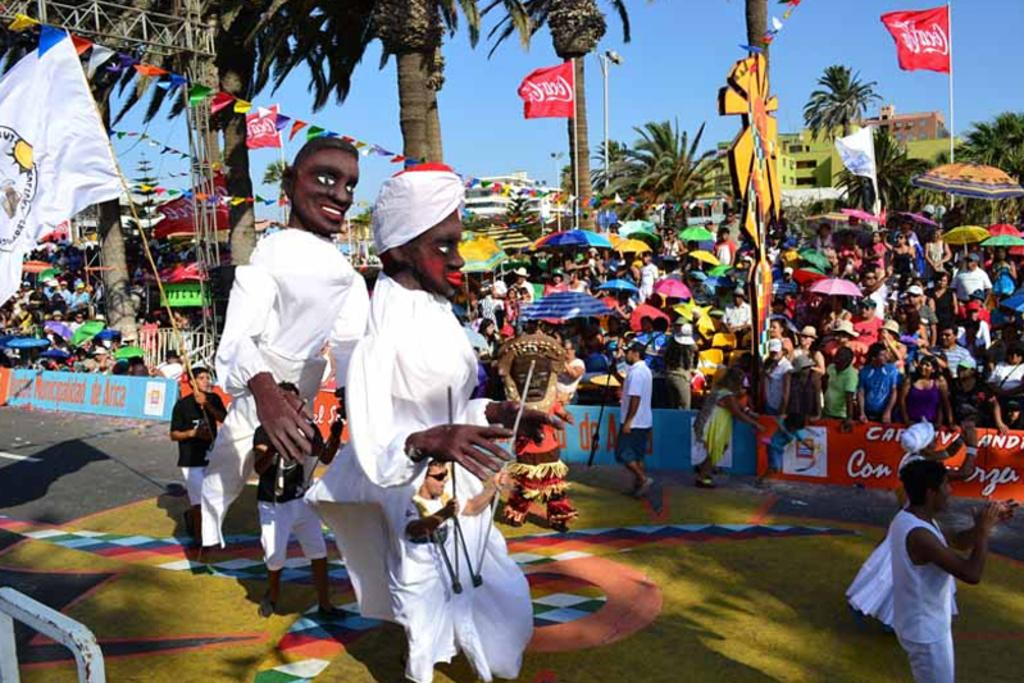<image>
Provide a brief description of the given image. Coca Cola banners are being flown at a festival in a tropical location. 